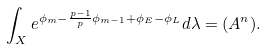<formula> <loc_0><loc_0><loc_500><loc_500>\int _ { X } e ^ { \phi _ { m } - \frac { p - 1 } p \phi _ { m - 1 } + \phi _ { E } - \phi _ { L } } d \lambda = ( A ^ { n } ) .</formula> 